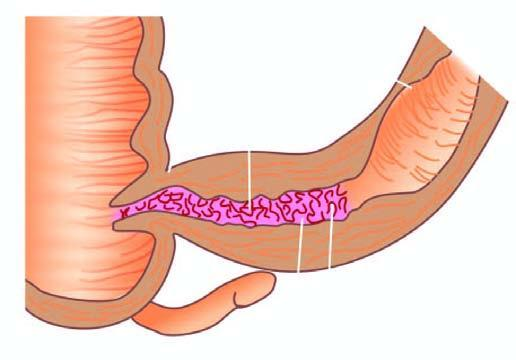s aboratory findings of itp shown in longitudinal section along with a segment in cross section?
Answer the question using a single word or phrase. No 